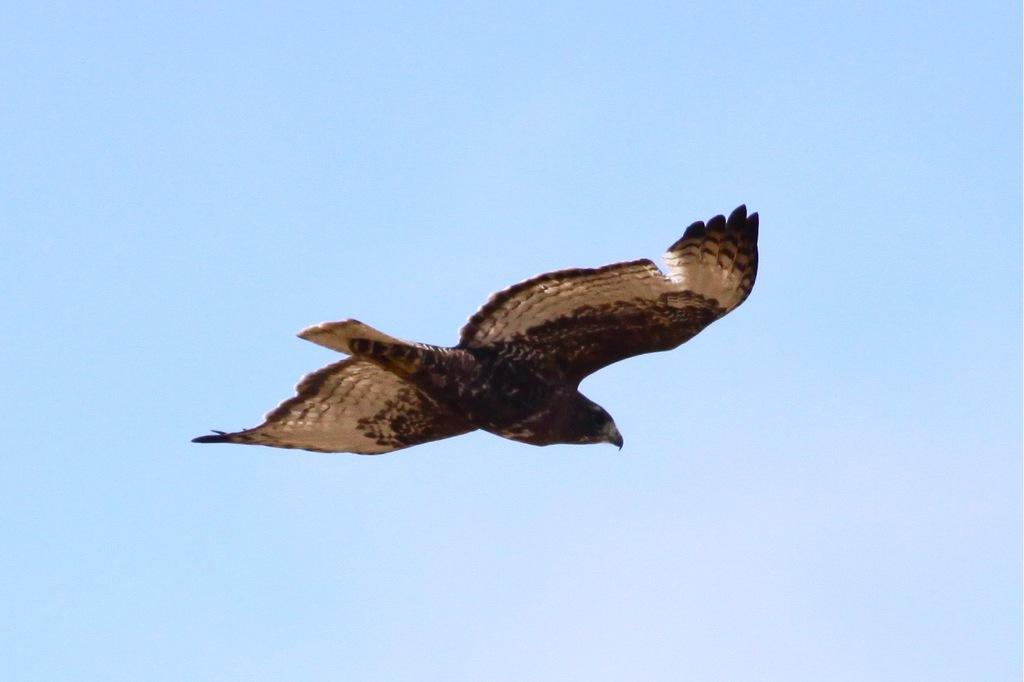What is the main subject in the center of the image? There is an eagle in the center of the image. What can be seen in the background of the image? The sky is visible in the background of the image. How would you describe the sky in the image? The sky appears to be clear in the image. What type of whip is being used by the donkey in the image? There is no donkey or whip present in the image; it features an eagle and a clear sky. 